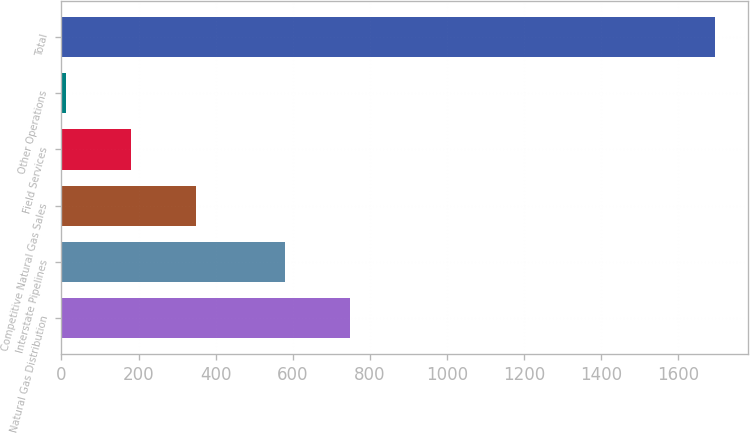Convert chart. <chart><loc_0><loc_0><loc_500><loc_500><bar_chart><fcel>Natural Gas Distribution<fcel>Interstate Pipelines<fcel>Competitive Natural Gas Sales<fcel>Field Services<fcel>Other Operations<fcel>Total<nl><fcel>747.5<fcel>579<fcel>348<fcel>179.5<fcel>11<fcel>1696<nl></chart> 